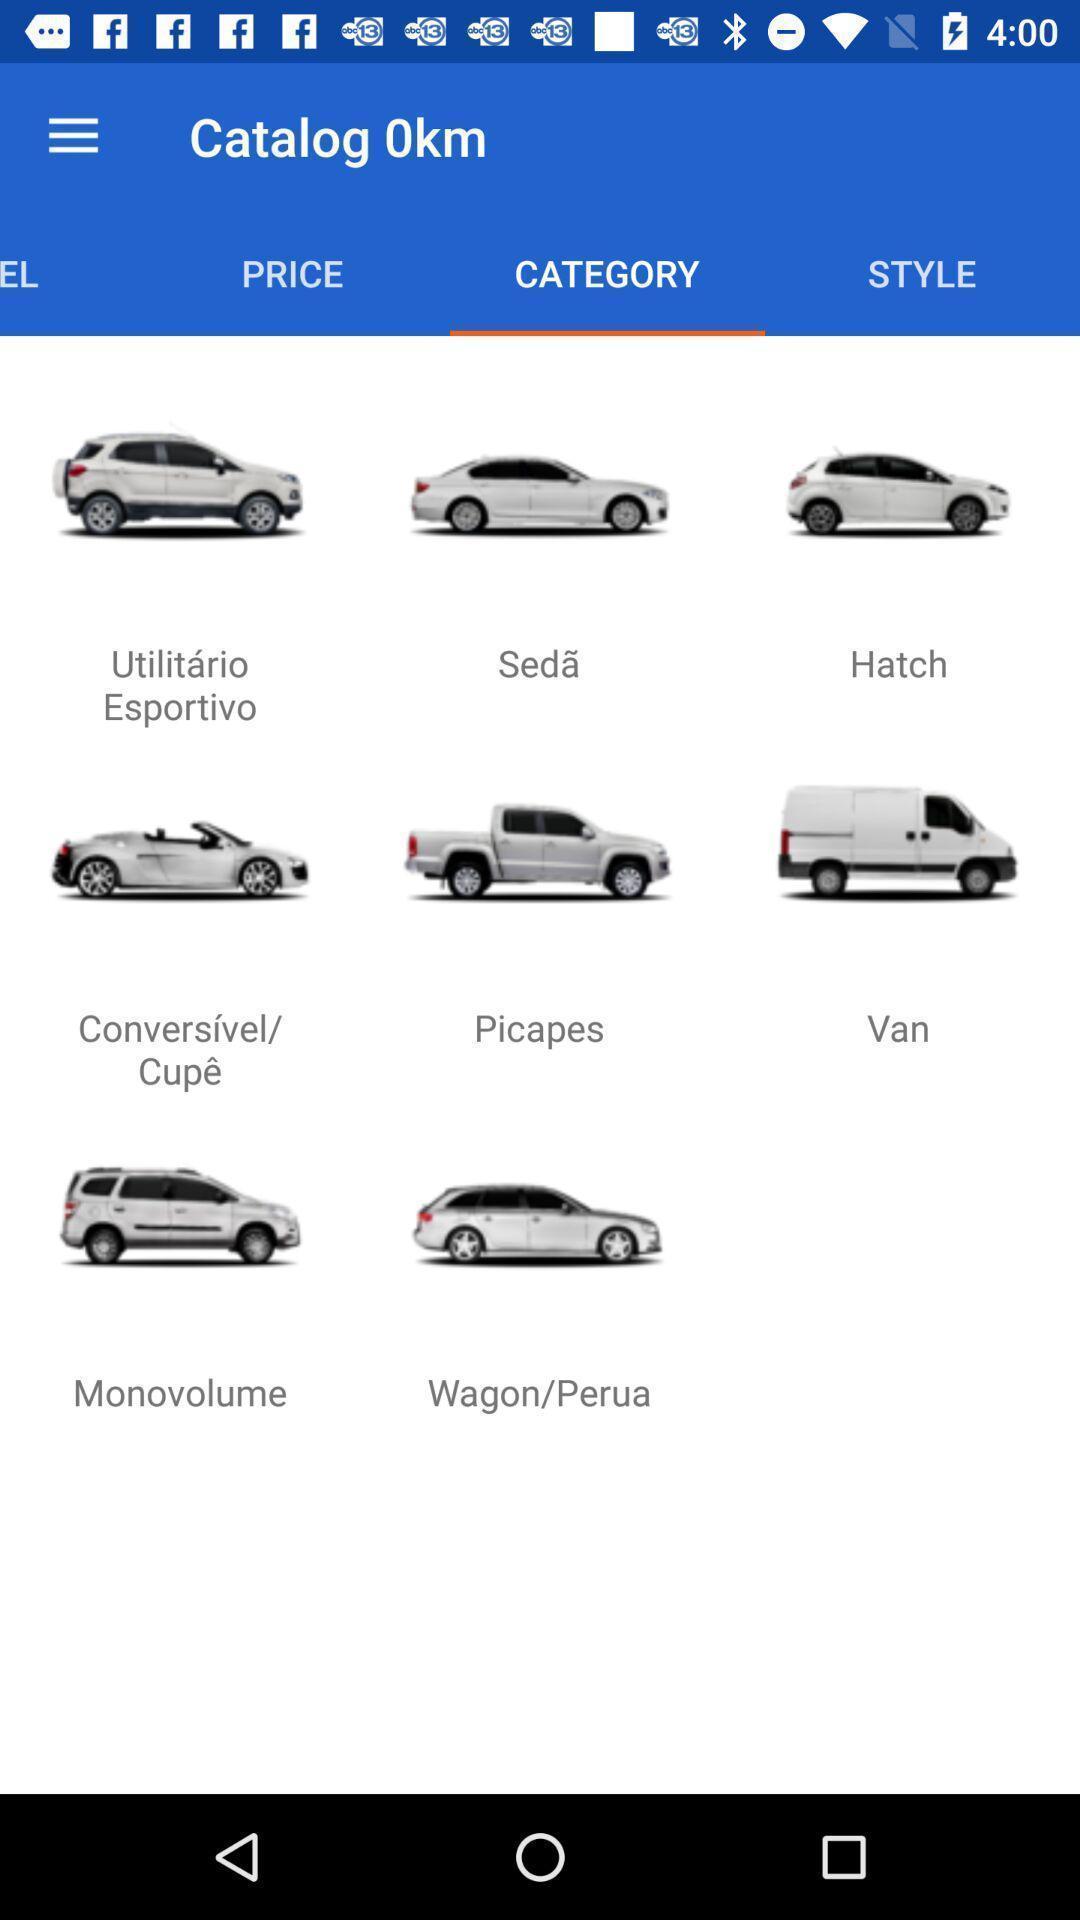Please provide a description for this image. Page displaying various cars with various options. 